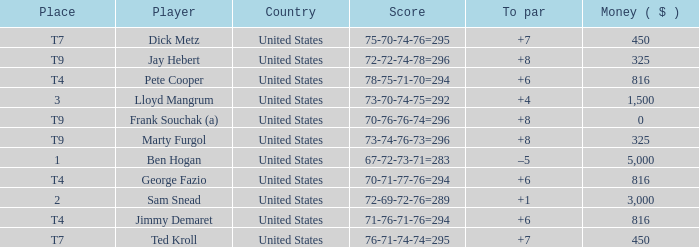What was Marty Furgol's place when he was paid less than $3,000? T9. 